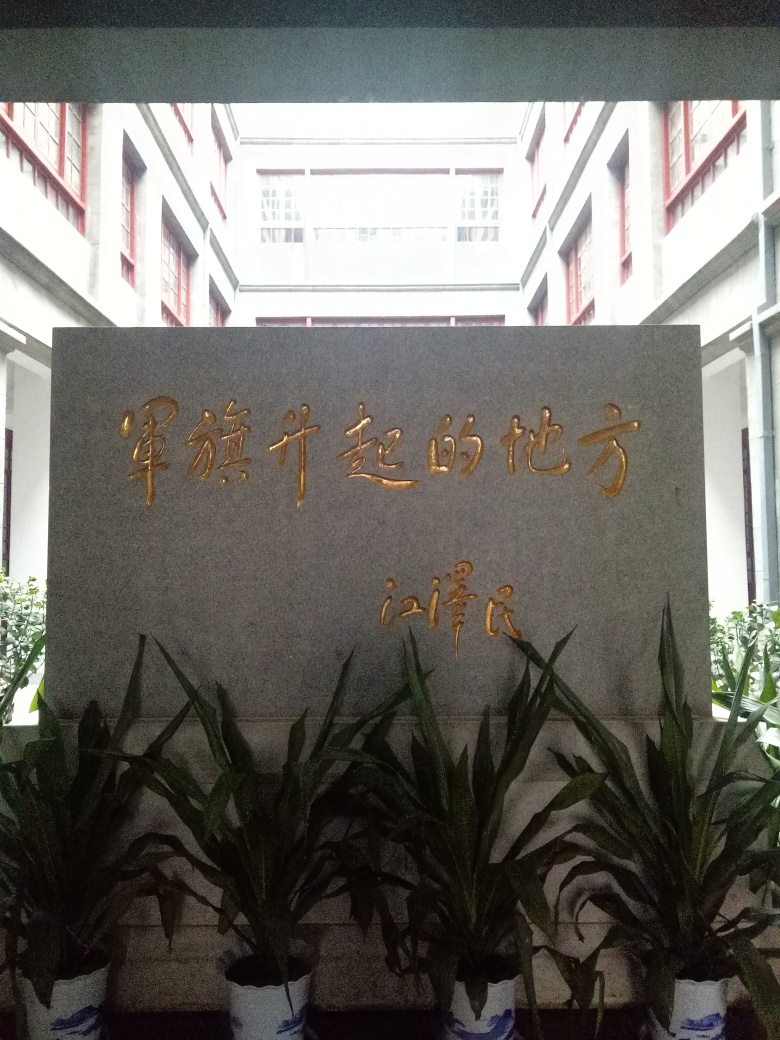What can you tell me about the text present in this image? The text appears to be in Chinese, and it seems to be a sign or placard, perhaps located in a place of importance like a school, government building, or a historical site. The golden characters suggest a formal or prestigious context. How could the image be improved to focus on the text? Improving the image could involve centering the text within the frame, enhancing the lighting on the characters to make them stand out more, and possibly capturing the image at a time of day when natural light reduced shadows on the text. 